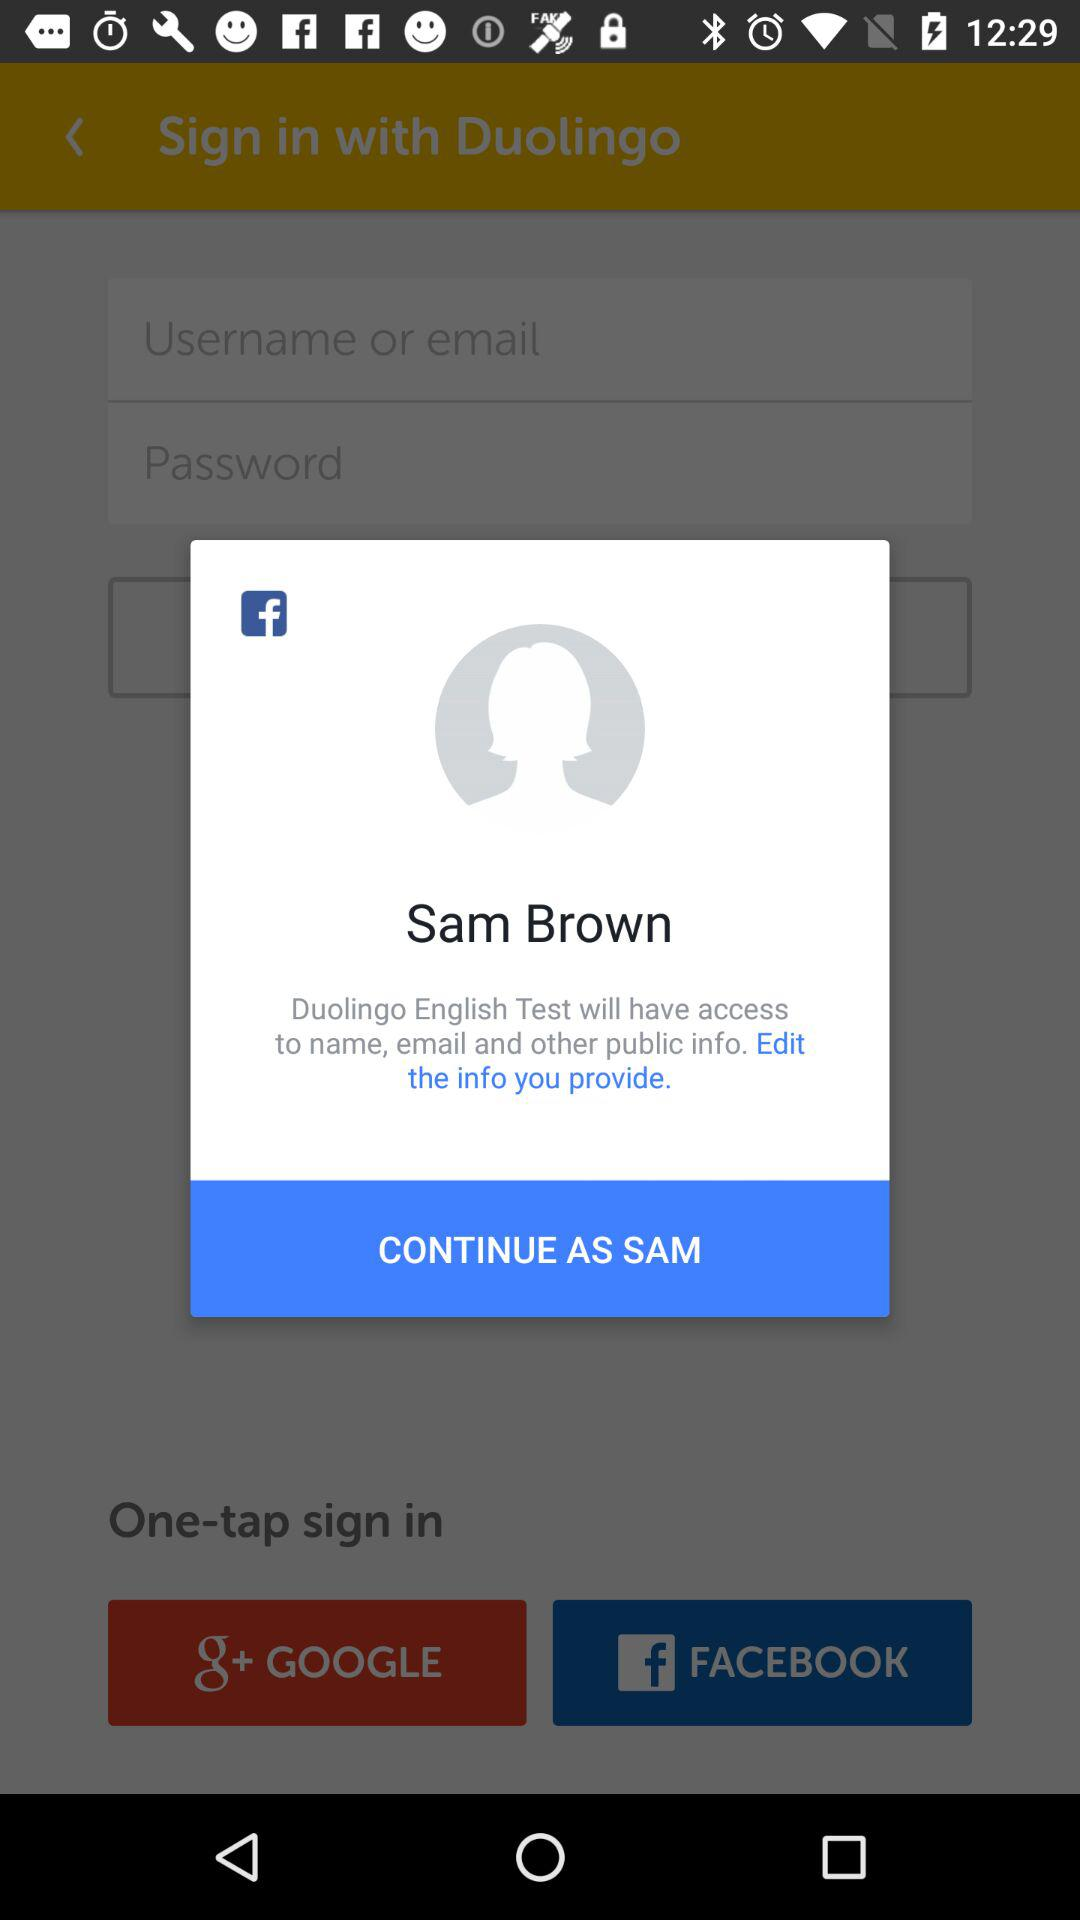Which accounts can be used to sign up? The accounts that can be used to sign up are "GOOGLE" and "FACEBOOK". 